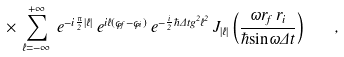Convert formula to latex. <formula><loc_0><loc_0><loc_500><loc_500>\times \, \sum _ { \ell = - \infty } ^ { + \infty } \, e ^ { - i \frac { \pi } { 2 } | \ell | } \, e ^ { i \ell ( \varphi _ { f } - \varphi _ { i } ) } \, e ^ { - \frac { i } { 2 } \hbar { \Delta } t g ^ { 2 } \ell ^ { 2 } } \, J _ { | \ell | } \left ( \frac { \omega r _ { f } \, r _ { i } } { \hbar { \sin } \omega \Delta t } \right ) \quad ,</formula> 